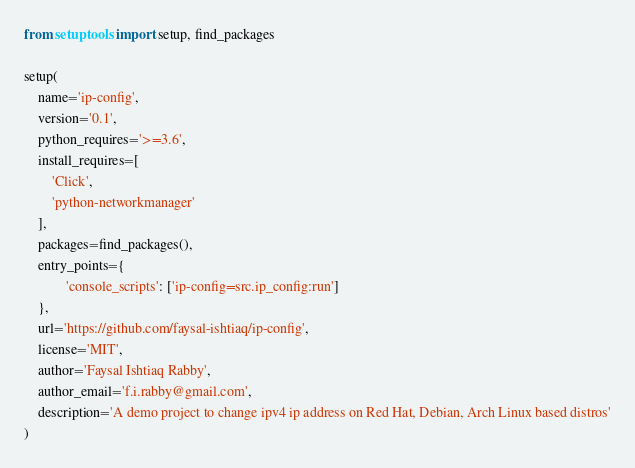<code> <loc_0><loc_0><loc_500><loc_500><_Python_>from setuptools import setup, find_packages

setup(
    name='ip-config',
    version='0.1',
    python_requires='>=3.6',
    install_requires=[
        'Click',
        'python-networkmanager'
    ],
    packages=find_packages(),
    entry_points={
            'console_scripts': ['ip-config=src.ip_config:run']
    },
    url='https://github.com/faysal-ishtiaq/ip-config',
    license='MIT',
    author='Faysal Ishtiaq Rabby',
    author_email='f.i.rabby@gmail.com',
    description='A demo project to change ipv4 ip address on Red Hat, Debian, Arch Linux based distros'
)
</code> 